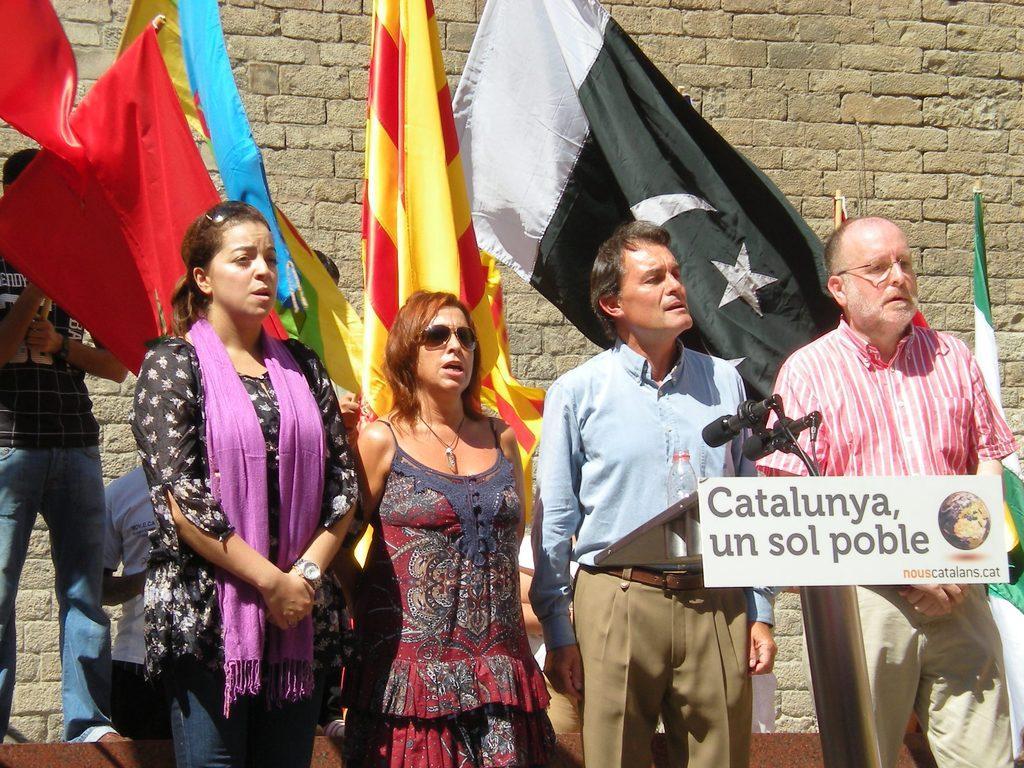How would you summarize this image in a sentence or two? In this picture we can see five people standing here, we can see microphones here, there is a bottle here, in the background we can see a wall and some flags, there is a board here. 